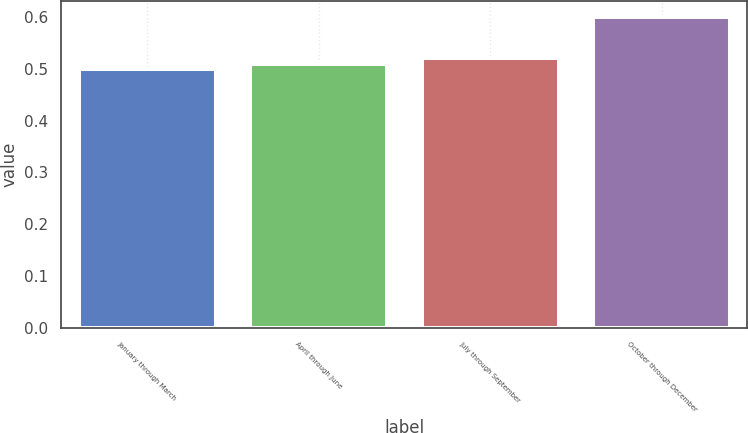Convert chart to OTSL. <chart><loc_0><loc_0><loc_500><loc_500><bar_chart><fcel>January through March<fcel>April through June<fcel>July through September<fcel>October through December<nl><fcel>0.5<fcel>0.51<fcel>0.52<fcel>0.6<nl></chart> 